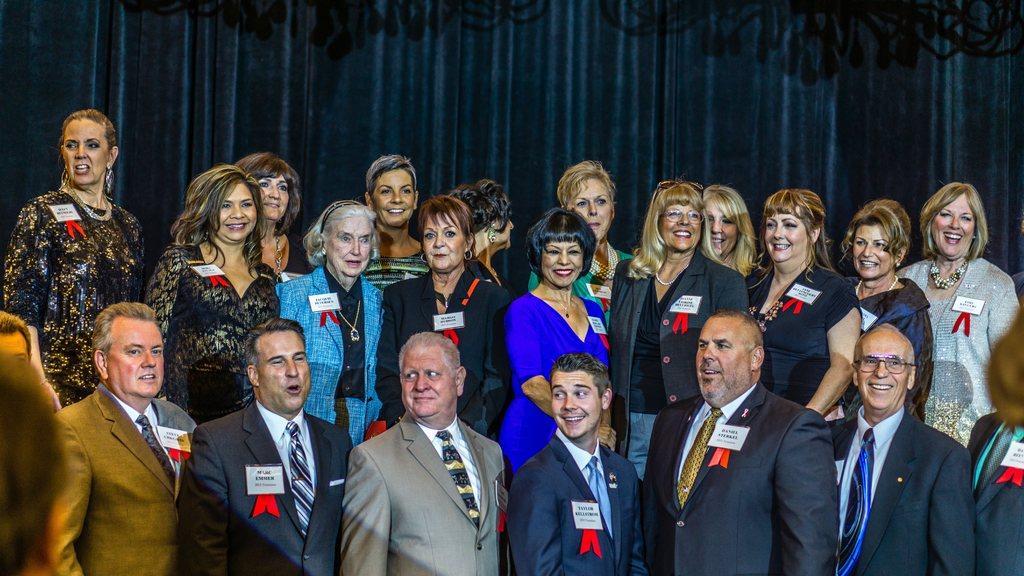In one or two sentences, can you explain what this image depicts? In this image we can see a group of people standing. There is a curtain in the image. 